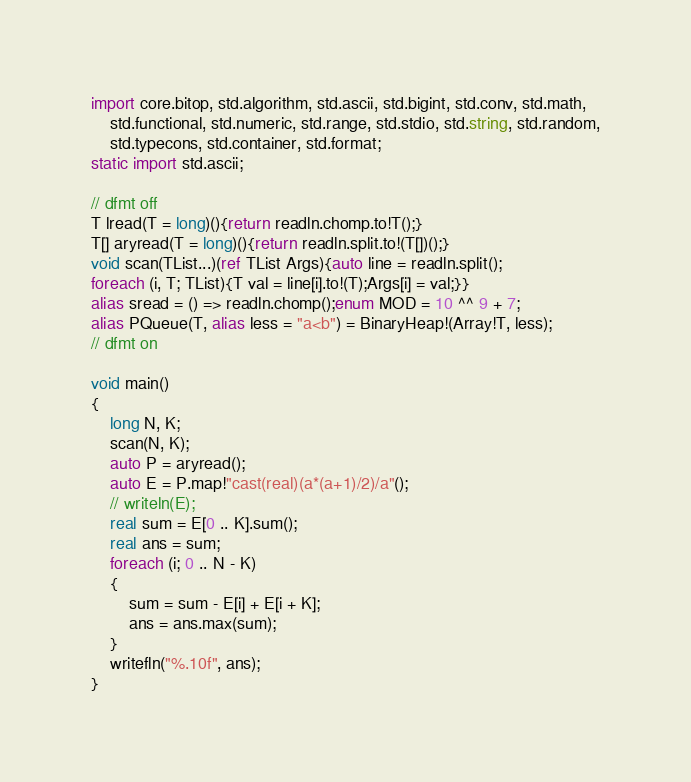<code> <loc_0><loc_0><loc_500><loc_500><_D_>import core.bitop, std.algorithm, std.ascii, std.bigint, std.conv, std.math,
    std.functional, std.numeric, std.range, std.stdio, std.string, std.random,
    std.typecons, std.container, std.format;
static import std.ascii;

// dfmt off
T lread(T = long)(){return readln.chomp.to!T();}
T[] aryread(T = long)(){return readln.split.to!(T[])();}
void scan(TList...)(ref TList Args){auto line = readln.split();
foreach (i, T; TList){T val = line[i].to!(T);Args[i] = val;}}
alias sread = () => readln.chomp();enum MOD = 10 ^^ 9 + 7;
alias PQueue(T, alias less = "a<b") = BinaryHeap!(Array!T, less);
// dfmt on

void main()
{
    long N, K;
    scan(N, K);
    auto P = aryread();
    auto E = P.map!"cast(real)(a*(a+1)/2)/a"();
    // writeln(E);
    real sum = E[0 .. K].sum();
    real ans = sum;
    foreach (i; 0 .. N - K)
    {
        sum = sum - E[i] + E[i + K];
        ans = ans.max(sum);
    }
    writefln("%.10f", ans);
}
</code> 